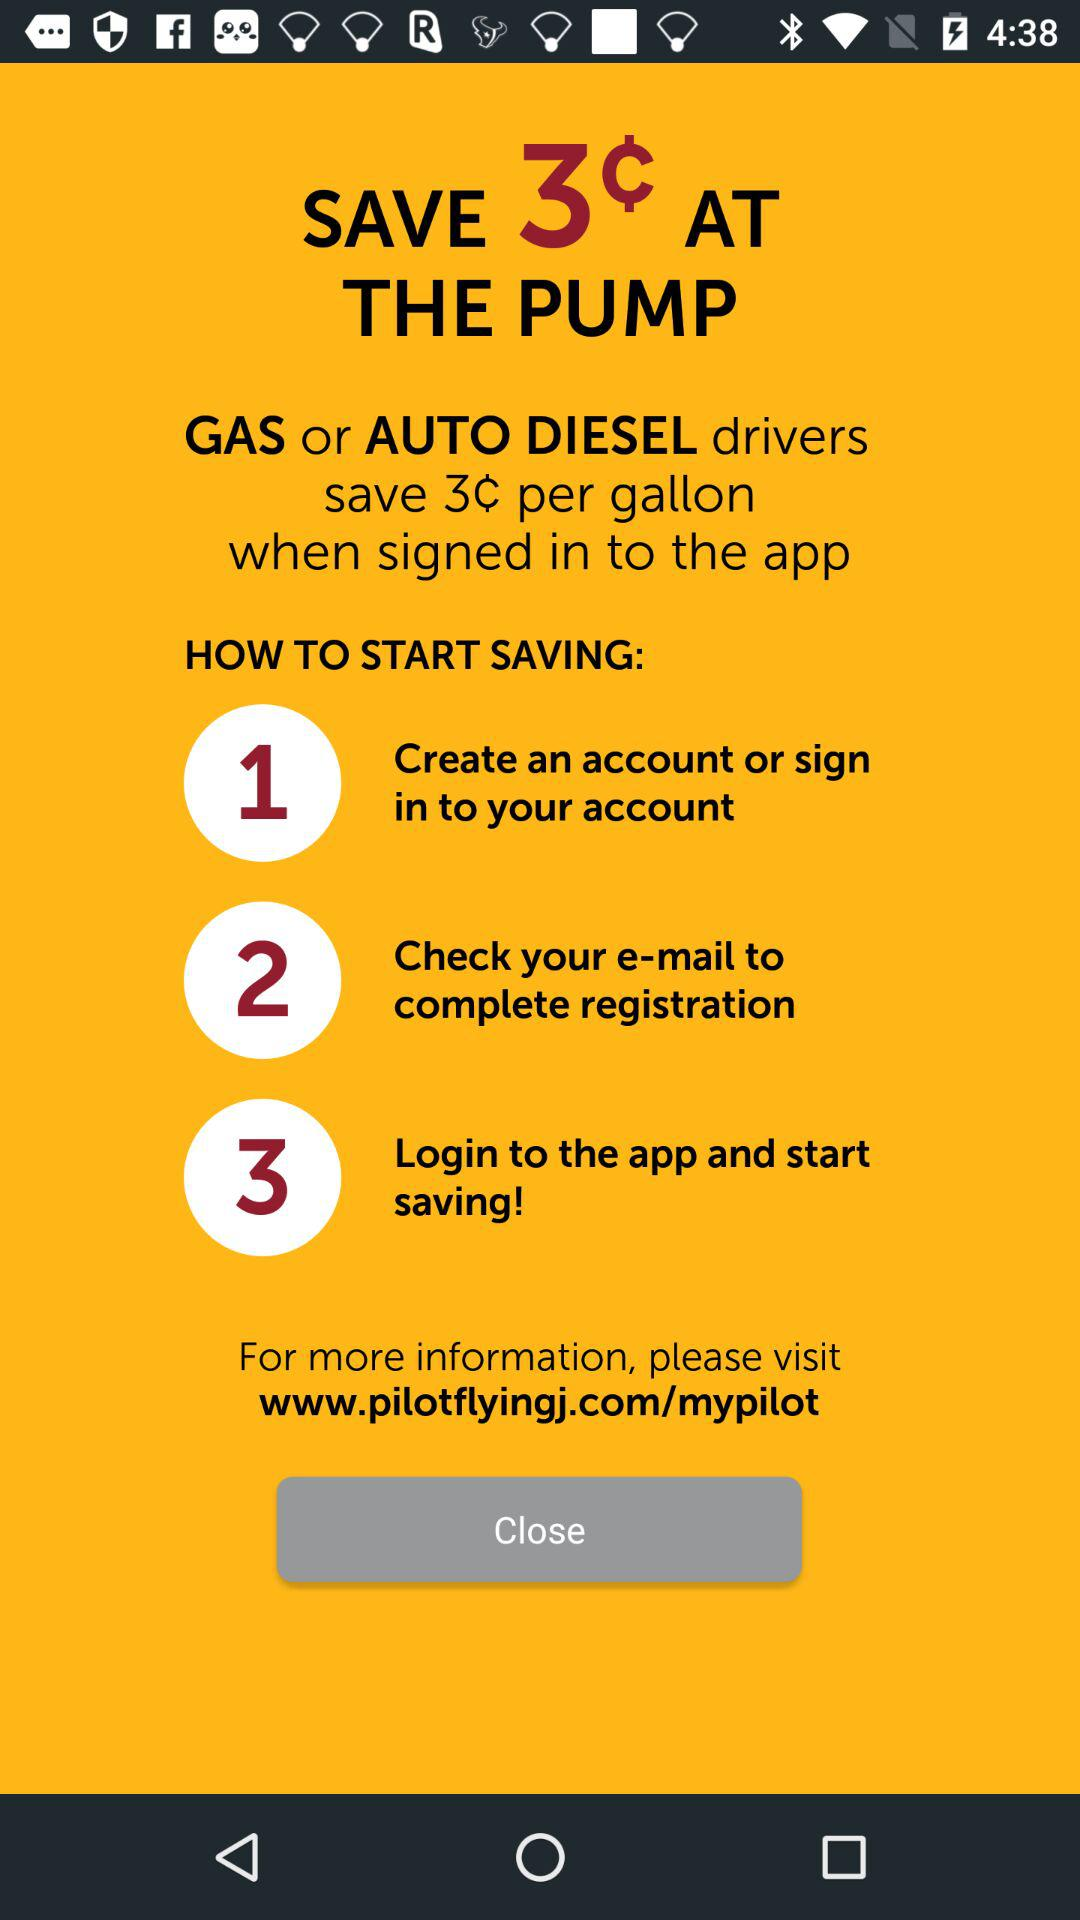How many steps are there in the process of saving 3¢ per gallon?
Answer the question using a single word or phrase. 3 